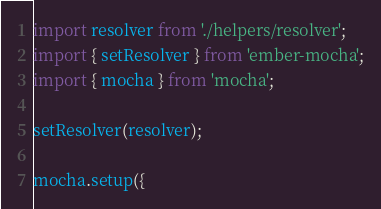Convert code to text. <code><loc_0><loc_0><loc_500><loc_500><_JavaScript_>import resolver from './helpers/resolver';
import { setResolver } from 'ember-mocha';
import { mocha } from 'mocha';

setResolver(resolver);

mocha.setup({</code> 